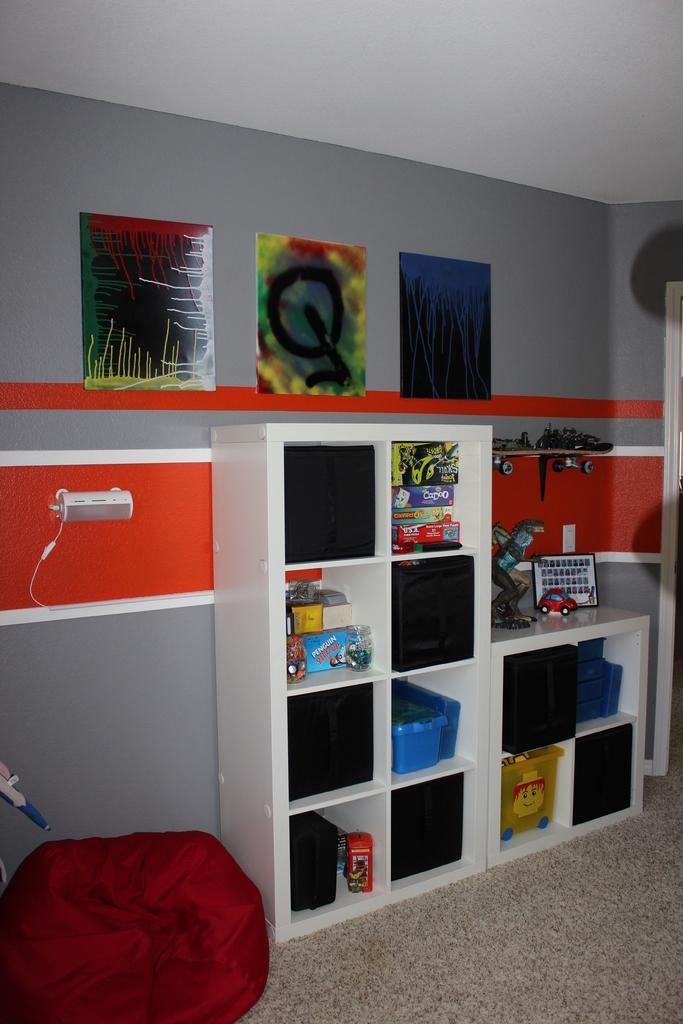What can be seen in the racks in the image? There are objects and toys placed in the racks. What can be identified as an electronic device in the image? There is a device visible in the image. What type of decorative items are on the wall? There are frames on a wall. What type of seating is present on the floor? There is a bean bag on the floor. What direction is the mist coming from in the image? There is no mist present in the image. Is there a trail visible in the image? There is no trail visible in the image. 